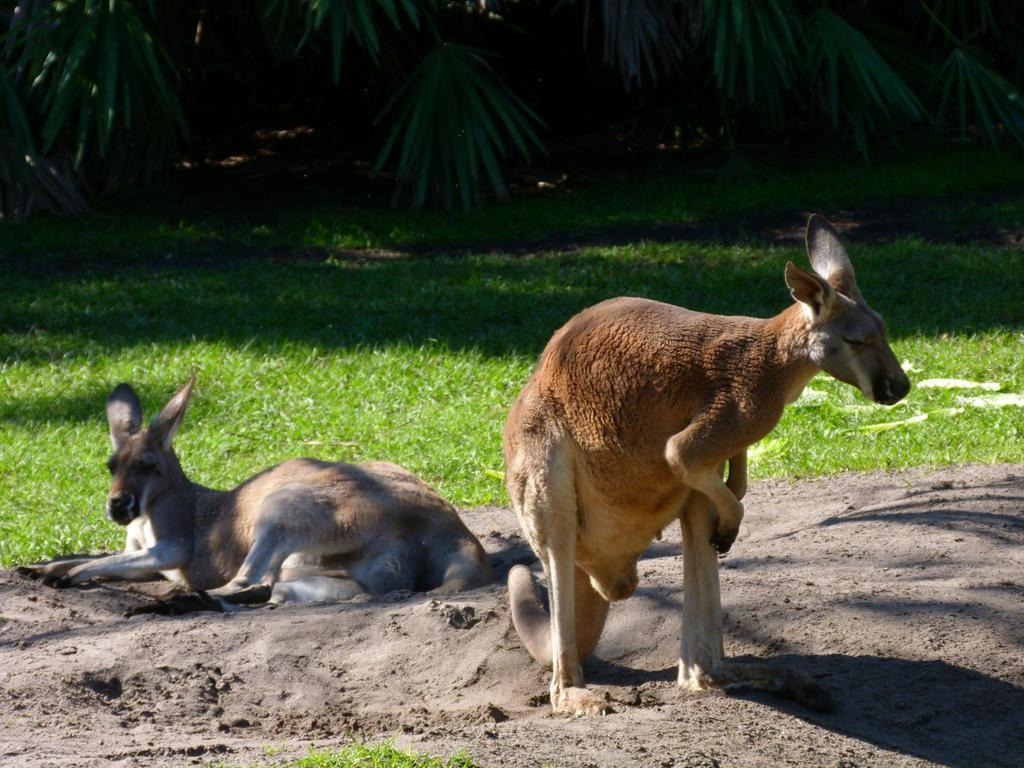What animals are present in the image? There are two kangaroos in the image. Where are the kangaroos located in the image? The kangaroos are in the front of the image. What type of terrain is visible in the background of the image? There is grass ground and trees visible in the background of the image. What can be observed on the ground in the image? There are shadows on the ground in the image. What type of cast can be seen on the kangaroo's leg in the image? There is no cast visible on the kangaroos' legs in the image. What type of meal are the kangaroos eating in the image? The kangaroos are not eating a meal in the image; they are simply standing on the grass ground. 